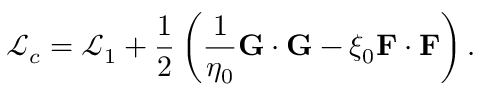<formula> <loc_0><loc_0><loc_500><loc_500>\mathcal { L } _ { c } = \mathcal { L } _ { 1 } + \frac { 1 } { 2 } \left ( \frac { 1 } { \eta _ { 0 } } G \cdot G - \xi _ { 0 } F \cdot F \right ) .</formula> 